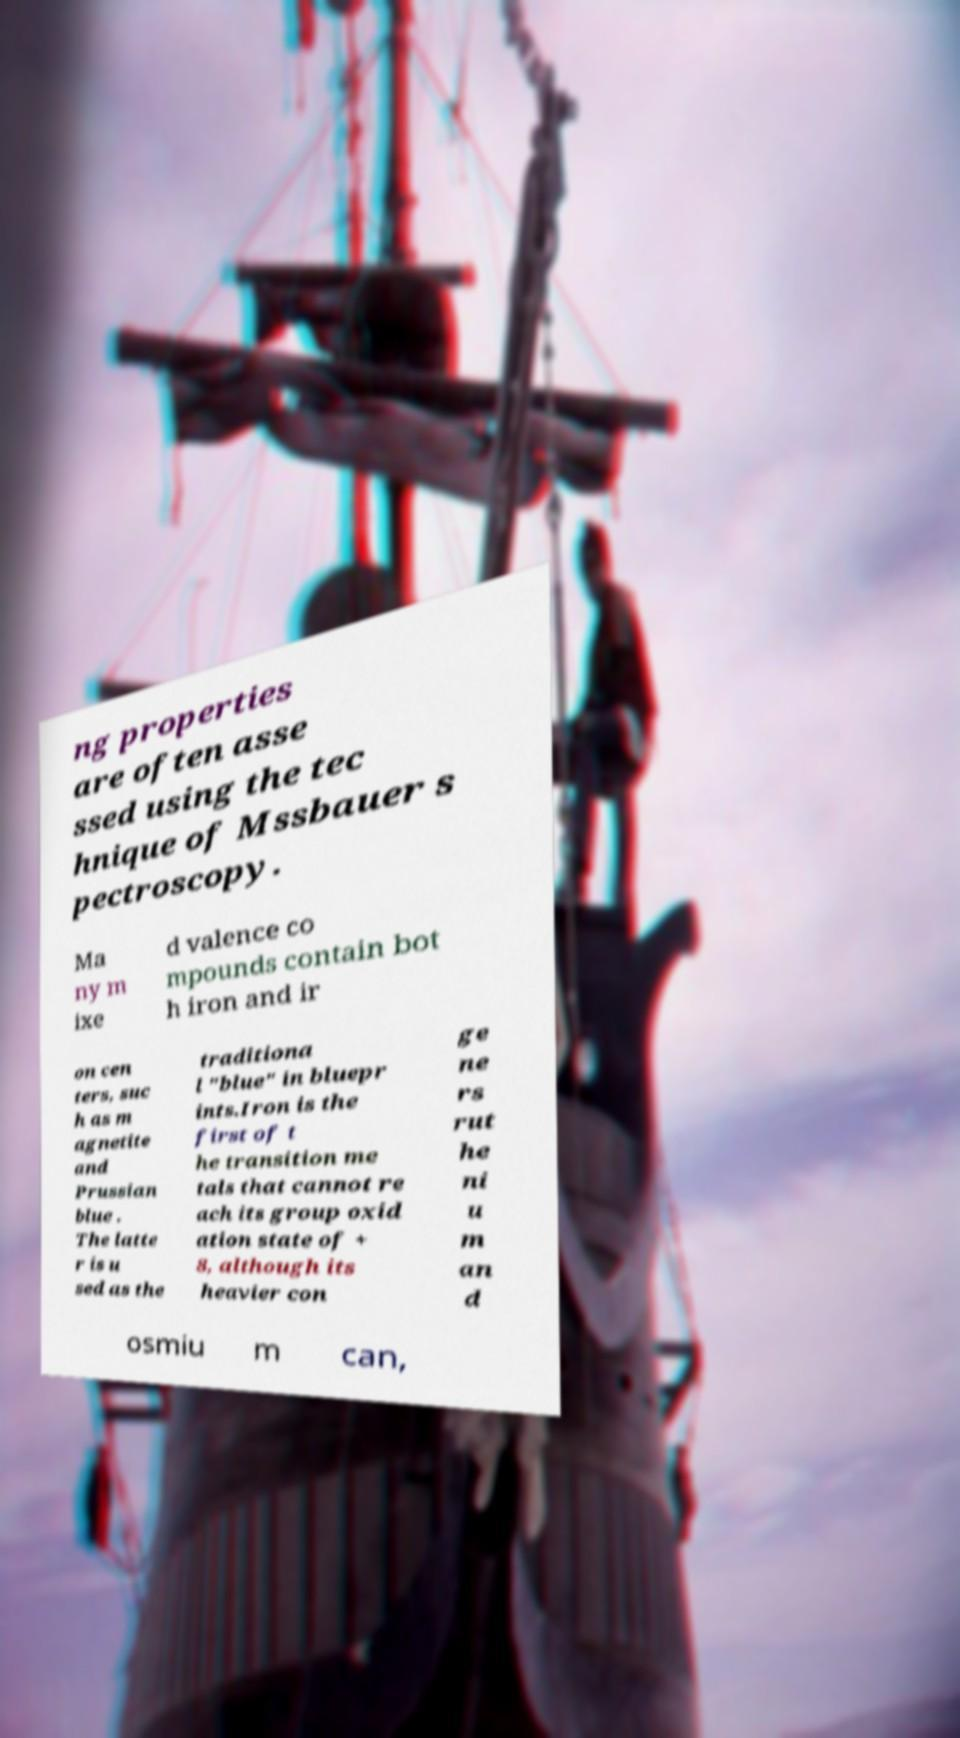Can you accurately transcribe the text from the provided image for me? ng properties are often asse ssed using the tec hnique of Mssbauer s pectroscopy. Ma ny m ixe d valence co mpounds contain bot h iron and ir on cen ters, suc h as m agnetite and Prussian blue . The latte r is u sed as the traditiona l "blue" in bluepr ints.Iron is the first of t he transition me tals that cannot re ach its group oxid ation state of + 8, although its heavier con ge ne rs rut he ni u m an d osmiu m can, 